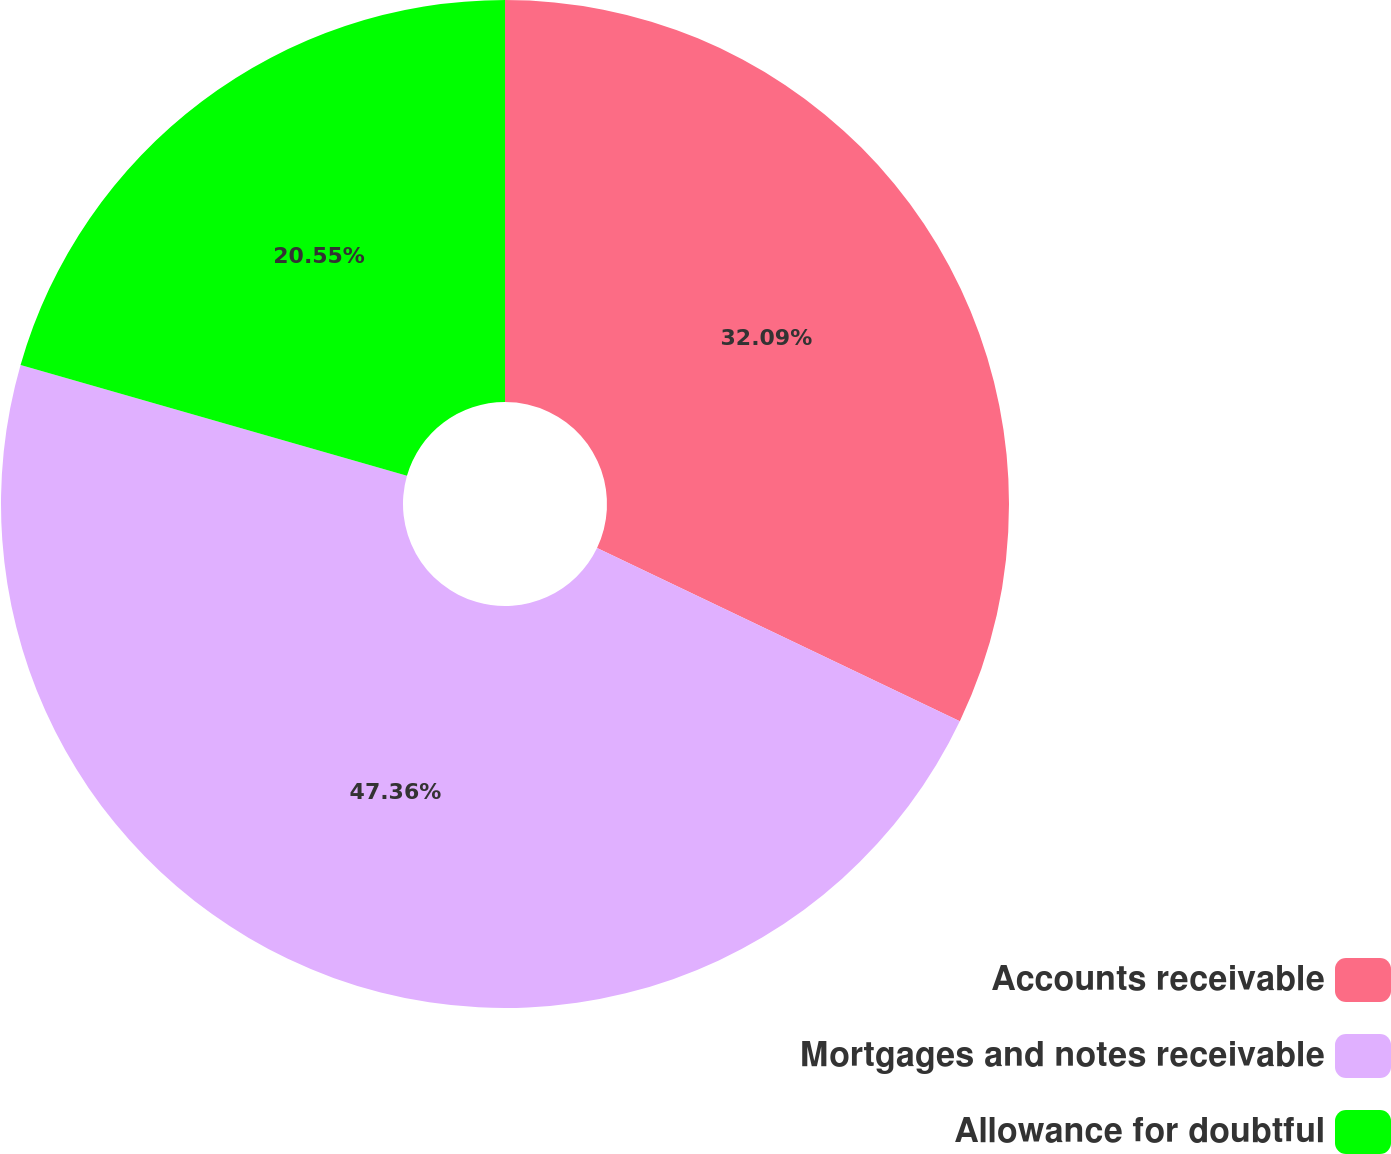Convert chart to OTSL. <chart><loc_0><loc_0><loc_500><loc_500><pie_chart><fcel>Accounts receivable<fcel>Mortgages and notes receivable<fcel>Allowance for doubtful<nl><fcel>32.09%<fcel>47.36%<fcel>20.55%<nl></chart> 